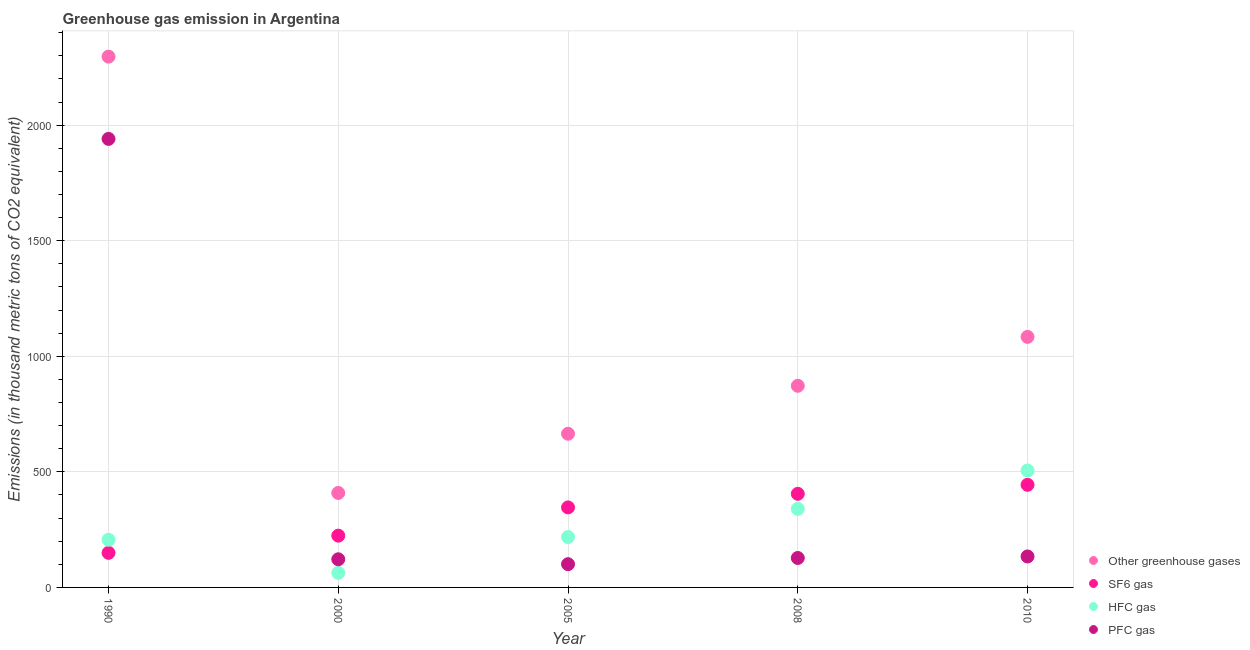Is the number of dotlines equal to the number of legend labels?
Ensure brevity in your answer.  Yes. What is the emission of greenhouse gases in 1990?
Provide a succinct answer. 2296.5. Across all years, what is the maximum emission of sf6 gas?
Keep it short and to the point. 444. Across all years, what is the minimum emission of pfc gas?
Your answer should be very brief. 100.6. What is the total emission of hfc gas in the graph?
Your answer should be very brief. 1333.4. What is the difference between the emission of greenhouse gases in 1990 and that in 2005?
Ensure brevity in your answer.  1631.6. What is the difference between the emission of hfc gas in 1990 and the emission of pfc gas in 2005?
Provide a short and direct response. 105.7. What is the average emission of greenhouse gases per year?
Provide a short and direct response. 1065.32. In the year 2010, what is the difference between the emission of pfc gas and emission of hfc gas?
Keep it short and to the point. -372. What is the ratio of the emission of pfc gas in 2005 to that in 2010?
Offer a very short reply. 0.75. What is the difference between the highest and the second highest emission of hfc gas?
Provide a short and direct response. 166. What is the difference between the highest and the lowest emission of sf6 gas?
Give a very brief answer. 294.4. Is the sum of the emission of pfc gas in 1990 and 2008 greater than the maximum emission of sf6 gas across all years?
Provide a short and direct response. Yes. Is it the case that in every year, the sum of the emission of greenhouse gases and emission of sf6 gas is greater than the emission of hfc gas?
Ensure brevity in your answer.  Yes. Does the emission of hfc gas monotonically increase over the years?
Provide a short and direct response. No. How many years are there in the graph?
Provide a succinct answer. 5. What is the difference between two consecutive major ticks on the Y-axis?
Ensure brevity in your answer.  500. Does the graph contain any zero values?
Provide a succinct answer. No. Does the graph contain grids?
Provide a short and direct response. Yes. Where does the legend appear in the graph?
Make the answer very short. Bottom right. What is the title of the graph?
Your response must be concise. Greenhouse gas emission in Argentina. Does "Offering training" appear as one of the legend labels in the graph?
Your response must be concise. No. What is the label or title of the X-axis?
Ensure brevity in your answer.  Year. What is the label or title of the Y-axis?
Your answer should be compact. Emissions (in thousand metric tons of CO2 equivalent). What is the Emissions (in thousand metric tons of CO2 equivalent) of Other greenhouse gases in 1990?
Your response must be concise. 2296.5. What is the Emissions (in thousand metric tons of CO2 equivalent) in SF6 gas in 1990?
Give a very brief answer. 149.6. What is the Emissions (in thousand metric tons of CO2 equivalent) in HFC gas in 1990?
Your response must be concise. 206.3. What is the Emissions (in thousand metric tons of CO2 equivalent) in PFC gas in 1990?
Your response must be concise. 1940.6. What is the Emissions (in thousand metric tons of CO2 equivalent) in Other greenhouse gases in 2000?
Ensure brevity in your answer.  408.8. What is the Emissions (in thousand metric tons of CO2 equivalent) of SF6 gas in 2000?
Offer a terse response. 224. What is the Emissions (in thousand metric tons of CO2 equivalent) in HFC gas in 2000?
Your response must be concise. 63. What is the Emissions (in thousand metric tons of CO2 equivalent) in PFC gas in 2000?
Make the answer very short. 121.8. What is the Emissions (in thousand metric tons of CO2 equivalent) of Other greenhouse gases in 2005?
Offer a very short reply. 664.9. What is the Emissions (in thousand metric tons of CO2 equivalent) in SF6 gas in 2005?
Your response must be concise. 346.2. What is the Emissions (in thousand metric tons of CO2 equivalent) in HFC gas in 2005?
Provide a succinct answer. 218.1. What is the Emissions (in thousand metric tons of CO2 equivalent) in PFC gas in 2005?
Your answer should be very brief. 100.6. What is the Emissions (in thousand metric tons of CO2 equivalent) in Other greenhouse gases in 2008?
Provide a short and direct response. 872.4. What is the Emissions (in thousand metric tons of CO2 equivalent) in SF6 gas in 2008?
Your response must be concise. 405. What is the Emissions (in thousand metric tons of CO2 equivalent) of HFC gas in 2008?
Give a very brief answer. 340. What is the Emissions (in thousand metric tons of CO2 equivalent) of PFC gas in 2008?
Keep it short and to the point. 127.4. What is the Emissions (in thousand metric tons of CO2 equivalent) of Other greenhouse gases in 2010?
Your answer should be compact. 1084. What is the Emissions (in thousand metric tons of CO2 equivalent) of SF6 gas in 2010?
Give a very brief answer. 444. What is the Emissions (in thousand metric tons of CO2 equivalent) in HFC gas in 2010?
Keep it short and to the point. 506. What is the Emissions (in thousand metric tons of CO2 equivalent) of PFC gas in 2010?
Make the answer very short. 134. Across all years, what is the maximum Emissions (in thousand metric tons of CO2 equivalent) in Other greenhouse gases?
Give a very brief answer. 2296.5. Across all years, what is the maximum Emissions (in thousand metric tons of CO2 equivalent) in SF6 gas?
Offer a very short reply. 444. Across all years, what is the maximum Emissions (in thousand metric tons of CO2 equivalent) in HFC gas?
Keep it short and to the point. 506. Across all years, what is the maximum Emissions (in thousand metric tons of CO2 equivalent) of PFC gas?
Give a very brief answer. 1940.6. Across all years, what is the minimum Emissions (in thousand metric tons of CO2 equivalent) in Other greenhouse gases?
Offer a very short reply. 408.8. Across all years, what is the minimum Emissions (in thousand metric tons of CO2 equivalent) of SF6 gas?
Provide a succinct answer. 149.6. Across all years, what is the minimum Emissions (in thousand metric tons of CO2 equivalent) in PFC gas?
Offer a very short reply. 100.6. What is the total Emissions (in thousand metric tons of CO2 equivalent) of Other greenhouse gases in the graph?
Your answer should be compact. 5326.6. What is the total Emissions (in thousand metric tons of CO2 equivalent) of SF6 gas in the graph?
Provide a succinct answer. 1568.8. What is the total Emissions (in thousand metric tons of CO2 equivalent) in HFC gas in the graph?
Provide a succinct answer. 1333.4. What is the total Emissions (in thousand metric tons of CO2 equivalent) in PFC gas in the graph?
Provide a succinct answer. 2424.4. What is the difference between the Emissions (in thousand metric tons of CO2 equivalent) of Other greenhouse gases in 1990 and that in 2000?
Keep it short and to the point. 1887.7. What is the difference between the Emissions (in thousand metric tons of CO2 equivalent) of SF6 gas in 1990 and that in 2000?
Offer a very short reply. -74.4. What is the difference between the Emissions (in thousand metric tons of CO2 equivalent) in HFC gas in 1990 and that in 2000?
Make the answer very short. 143.3. What is the difference between the Emissions (in thousand metric tons of CO2 equivalent) of PFC gas in 1990 and that in 2000?
Make the answer very short. 1818.8. What is the difference between the Emissions (in thousand metric tons of CO2 equivalent) in Other greenhouse gases in 1990 and that in 2005?
Ensure brevity in your answer.  1631.6. What is the difference between the Emissions (in thousand metric tons of CO2 equivalent) of SF6 gas in 1990 and that in 2005?
Give a very brief answer. -196.6. What is the difference between the Emissions (in thousand metric tons of CO2 equivalent) in PFC gas in 1990 and that in 2005?
Give a very brief answer. 1840. What is the difference between the Emissions (in thousand metric tons of CO2 equivalent) of Other greenhouse gases in 1990 and that in 2008?
Your response must be concise. 1424.1. What is the difference between the Emissions (in thousand metric tons of CO2 equivalent) of SF6 gas in 1990 and that in 2008?
Ensure brevity in your answer.  -255.4. What is the difference between the Emissions (in thousand metric tons of CO2 equivalent) of HFC gas in 1990 and that in 2008?
Keep it short and to the point. -133.7. What is the difference between the Emissions (in thousand metric tons of CO2 equivalent) of PFC gas in 1990 and that in 2008?
Provide a short and direct response. 1813.2. What is the difference between the Emissions (in thousand metric tons of CO2 equivalent) of Other greenhouse gases in 1990 and that in 2010?
Give a very brief answer. 1212.5. What is the difference between the Emissions (in thousand metric tons of CO2 equivalent) in SF6 gas in 1990 and that in 2010?
Ensure brevity in your answer.  -294.4. What is the difference between the Emissions (in thousand metric tons of CO2 equivalent) in HFC gas in 1990 and that in 2010?
Offer a terse response. -299.7. What is the difference between the Emissions (in thousand metric tons of CO2 equivalent) in PFC gas in 1990 and that in 2010?
Keep it short and to the point. 1806.6. What is the difference between the Emissions (in thousand metric tons of CO2 equivalent) of Other greenhouse gases in 2000 and that in 2005?
Keep it short and to the point. -256.1. What is the difference between the Emissions (in thousand metric tons of CO2 equivalent) in SF6 gas in 2000 and that in 2005?
Your answer should be compact. -122.2. What is the difference between the Emissions (in thousand metric tons of CO2 equivalent) in HFC gas in 2000 and that in 2005?
Offer a terse response. -155.1. What is the difference between the Emissions (in thousand metric tons of CO2 equivalent) in PFC gas in 2000 and that in 2005?
Your answer should be compact. 21.2. What is the difference between the Emissions (in thousand metric tons of CO2 equivalent) in Other greenhouse gases in 2000 and that in 2008?
Give a very brief answer. -463.6. What is the difference between the Emissions (in thousand metric tons of CO2 equivalent) in SF6 gas in 2000 and that in 2008?
Provide a short and direct response. -181. What is the difference between the Emissions (in thousand metric tons of CO2 equivalent) in HFC gas in 2000 and that in 2008?
Keep it short and to the point. -277. What is the difference between the Emissions (in thousand metric tons of CO2 equivalent) of Other greenhouse gases in 2000 and that in 2010?
Provide a short and direct response. -675.2. What is the difference between the Emissions (in thousand metric tons of CO2 equivalent) of SF6 gas in 2000 and that in 2010?
Your answer should be very brief. -220. What is the difference between the Emissions (in thousand metric tons of CO2 equivalent) of HFC gas in 2000 and that in 2010?
Make the answer very short. -443. What is the difference between the Emissions (in thousand metric tons of CO2 equivalent) in PFC gas in 2000 and that in 2010?
Your response must be concise. -12.2. What is the difference between the Emissions (in thousand metric tons of CO2 equivalent) in Other greenhouse gases in 2005 and that in 2008?
Your answer should be very brief. -207.5. What is the difference between the Emissions (in thousand metric tons of CO2 equivalent) in SF6 gas in 2005 and that in 2008?
Make the answer very short. -58.8. What is the difference between the Emissions (in thousand metric tons of CO2 equivalent) of HFC gas in 2005 and that in 2008?
Make the answer very short. -121.9. What is the difference between the Emissions (in thousand metric tons of CO2 equivalent) in PFC gas in 2005 and that in 2008?
Offer a terse response. -26.8. What is the difference between the Emissions (in thousand metric tons of CO2 equivalent) of Other greenhouse gases in 2005 and that in 2010?
Provide a succinct answer. -419.1. What is the difference between the Emissions (in thousand metric tons of CO2 equivalent) of SF6 gas in 2005 and that in 2010?
Offer a terse response. -97.8. What is the difference between the Emissions (in thousand metric tons of CO2 equivalent) of HFC gas in 2005 and that in 2010?
Ensure brevity in your answer.  -287.9. What is the difference between the Emissions (in thousand metric tons of CO2 equivalent) in PFC gas in 2005 and that in 2010?
Your answer should be very brief. -33.4. What is the difference between the Emissions (in thousand metric tons of CO2 equivalent) in Other greenhouse gases in 2008 and that in 2010?
Give a very brief answer. -211.6. What is the difference between the Emissions (in thousand metric tons of CO2 equivalent) of SF6 gas in 2008 and that in 2010?
Your response must be concise. -39. What is the difference between the Emissions (in thousand metric tons of CO2 equivalent) in HFC gas in 2008 and that in 2010?
Your answer should be very brief. -166. What is the difference between the Emissions (in thousand metric tons of CO2 equivalent) of Other greenhouse gases in 1990 and the Emissions (in thousand metric tons of CO2 equivalent) of SF6 gas in 2000?
Offer a very short reply. 2072.5. What is the difference between the Emissions (in thousand metric tons of CO2 equivalent) in Other greenhouse gases in 1990 and the Emissions (in thousand metric tons of CO2 equivalent) in HFC gas in 2000?
Give a very brief answer. 2233.5. What is the difference between the Emissions (in thousand metric tons of CO2 equivalent) of Other greenhouse gases in 1990 and the Emissions (in thousand metric tons of CO2 equivalent) of PFC gas in 2000?
Offer a very short reply. 2174.7. What is the difference between the Emissions (in thousand metric tons of CO2 equivalent) in SF6 gas in 1990 and the Emissions (in thousand metric tons of CO2 equivalent) in HFC gas in 2000?
Ensure brevity in your answer.  86.6. What is the difference between the Emissions (in thousand metric tons of CO2 equivalent) in SF6 gas in 1990 and the Emissions (in thousand metric tons of CO2 equivalent) in PFC gas in 2000?
Keep it short and to the point. 27.8. What is the difference between the Emissions (in thousand metric tons of CO2 equivalent) in HFC gas in 1990 and the Emissions (in thousand metric tons of CO2 equivalent) in PFC gas in 2000?
Give a very brief answer. 84.5. What is the difference between the Emissions (in thousand metric tons of CO2 equivalent) in Other greenhouse gases in 1990 and the Emissions (in thousand metric tons of CO2 equivalent) in SF6 gas in 2005?
Give a very brief answer. 1950.3. What is the difference between the Emissions (in thousand metric tons of CO2 equivalent) of Other greenhouse gases in 1990 and the Emissions (in thousand metric tons of CO2 equivalent) of HFC gas in 2005?
Make the answer very short. 2078.4. What is the difference between the Emissions (in thousand metric tons of CO2 equivalent) in Other greenhouse gases in 1990 and the Emissions (in thousand metric tons of CO2 equivalent) in PFC gas in 2005?
Make the answer very short. 2195.9. What is the difference between the Emissions (in thousand metric tons of CO2 equivalent) in SF6 gas in 1990 and the Emissions (in thousand metric tons of CO2 equivalent) in HFC gas in 2005?
Your answer should be very brief. -68.5. What is the difference between the Emissions (in thousand metric tons of CO2 equivalent) in HFC gas in 1990 and the Emissions (in thousand metric tons of CO2 equivalent) in PFC gas in 2005?
Ensure brevity in your answer.  105.7. What is the difference between the Emissions (in thousand metric tons of CO2 equivalent) of Other greenhouse gases in 1990 and the Emissions (in thousand metric tons of CO2 equivalent) of SF6 gas in 2008?
Ensure brevity in your answer.  1891.5. What is the difference between the Emissions (in thousand metric tons of CO2 equivalent) of Other greenhouse gases in 1990 and the Emissions (in thousand metric tons of CO2 equivalent) of HFC gas in 2008?
Keep it short and to the point. 1956.5. What is the difference between the Emissions (in thousand metric tons of CO2 equivalent) of Other greenhouse gases in 1990 and the Emissions (in thousand metric tons of CO2 equivalent) of PFC gas in 2008?
Your answer should be very brief. 2169.1. What is the difference between the Emissions (in thousand metric tons of CO2 equivalent) in SF6 gas in 1990 and the Emissions (in thousand metric tons of CO2 equivalent) in HFC gas in 2008?
Offer a terse response. -190.4. What is the difference between the Emissions (in thousand metric tons of CO2 equivalent) in HFC gas in 1990 and the Emissions (in thousand metric tons of CO2 equivalent) in PFC gas in 2008?
Your response must be concise. 78.9. What is the difference between the Emissions (in thousand metric tons of CO2 equivalent) of Other greenhouse gases in 1990 and the Emissions (in thousand metric tons of CO2 equivalent) of SF6 gas in 2010?
Provide a short and direct response. 1852.5. What is the difference between the Emissions (in thousand metric tons of CO2 equivalent) of Other greenhouse gases in 1990 and the Emissions (in thousand metric tons of CO2 equivalent) of HFC gas in 2010?
Give a very brief answer. 1790.5. What is the difference between the Emissions (in thousand metric tons of CO2 equivalent) in Other greenhouse gases in 1990 and the Emissions (in thousand metric tons of CO2 equivalent) in PFC gas in 2010?
Provide a succinct answer. 2162.5. What is the difference between the Emissions (in thousand metric tons of CO2 equivalent) in SF6 gas in 1990 and the Emissions (in thousand metric tons of CO2 equivalent) in HFC gas in 2010?
Give a very brief answer. -356.4. What is the difference between the Emissions (in thousand metric tons of CO2 equivalent) of HFC gas in 1990 and the Emissions (in thousand metric tons of CO2 equivalent) of PFC gas in 2010?
Your answer should be compact. 72.3. What is the difference between the Emissions (in thousand metric tons of CO2 equivalent) in Other greenhouse gases in 2000 and the Emissions (in thousand metric tons of CO2 equivalent) in SF6 gas in 2005?
Offer a very short reply. 62.6. What is the difference between the Emissions (in thousand metric tons of CO2 equivalent) of Other greenhouse gases in 2000 and the Emissions (in thousand metric tons of CO2 equivalent) of HFC gas in 2005?
Your answer should be very brief. 190.7. What is the difference between the Emissions (in thousand metric tons of CO2 equivalent) in Other greenhouse gases in 2000 and the Emissions (in thousand metric tons of CO2 equivalent) in PFC gas in 2005?
Your answer should be compact. 308.2. What is the difference between the Emissions (in thousand metric tons of CO2 equivalent) in SF6 gas in 2000 and the Emissions (in thousand metric tons of CO2 equivalent) in HFC gas in 2005?
Offer a terse response. 5.9. What is the difference between the Emissions (in thousand metric tons of CO2 equivalent) of SF6 gas in 2000 and the Emissions (in thousand metric tons of CO2 equivalent) of PFC gas in 2005?
Your response must be concise. 123.4. What is the difference between the Emissions (in thousand metric tons of CO2 equivalent) of HFC gas in 2000 and the Emissions (in thousand metric tons of CO2 equivalent) of PFC gas in 2005?
Provide a succinct answer. -37.6. What is the difference between the Emissions (in thousand metric tons of CO2 equivalent) in Other greenhouse gases in 2000 and the Emissions (in thousand metric tons of CO2 equivalent) in HFC gas in 2008?
Your answer should be very brief. 68.8. What is the difference between the Emissions (in thousand metric tons of CO2 equivalent) of Other greenhouse gases in 2000 and the Emissions (in thousand metric tons of CO2 equivalent) of PFC gas in 2008?
Offer a very short reply. 281.4. What is the difference between the Emissions (in thousand metric tons of CO2 equivalent) of SF6 gas in 2000 and the Emissions (in thousand metric tons of CO2 equivalent) of HFC gas in 2008?
Provide a succinct answer. -116. What is the difference between the Emissions (in thousand metric tons of CO2 equivalent) of SF6 gas in 2000 and the Emissions (in thousand metric tons of CO2 equivalent) of PFC gas in 2008?
Your response must be concise. 96.6. What is the difference between the Emissions (in thousand metric tons of CO2 equivalent) in HFC gas in 2000 and the Emissions (in thousand metric tons of CO2 equivalent) in PFC gas in 2008?
Provide a short and direct response. -64.4. What is the difference between the Emissions (in thousand metric tons of CO2 equivalent) of Other greenhouse gases in 2000 and the Emissions (in thousand metric tons of CO2 equivalent) of SF6 gas in 2010?
Make the answer very short. -35.2. What is the difference between the Emissions (in thousand metric tons of CO2 equivalent) of Other greenhouse gases in 2000 and the Emissions (in thousand metric tons of CO2 equivalent) of HFC gas in 2010?
Your answer should be very brief. -97.2. What is the difference between the Emissions (in thousand metric tons of CO2 equivalent) in Other greenhouse gases in 2000 and the Emissions (in thousand metric tons of CO2 equivalent) in PFC gas in 2010?
Provide a short and direct response. 274.8. What is the difference between the Emissions (in thousand metric tons of CO2 equivalent) of SF6 gas in 2000 and the Emissions (in thousand metric tons of CO2 equivalent) of HFC gas in 2010?
Offer a terse response. -282. What is the difference between the Emissions (in thousand metric tons of CO2 equivalent) in HFC gas in 2000 and the Emissions (in thousand metric tons of CO2 equivalent) in PFC gas in 2010?
Offer a terse response. -71. What is the difference between the Emissions (in thousand metric tons of CO2 equivalent) of Other greenhouse gases in 2005 and the Emissions (in thousand metric tons of CO2 equivalent) of SF6 gas in 2008?
Your response must be concise. 259.9. What is the difference between the Emissions (in thousand metric tons of CO2 equivalent) of Other greenhouse gases in 2005 and the Emissions (in thousand metric tons of CO2 equivalent) of HFC gas in 2008?
Offer a very short reply. 324.9. What is the difference between the Emissions (in thousand metric tons of CO2 equivalent) of Other greenhouse gases in 2005 and the Emissions (in thousand metric tons of CO2 equivalent) of PFC gas in 2008?
Provide a short and direct response. 537.5. What is the difference between the Emissions (in thousand metric tons of CO2 equivalent) in SF6 gas in 2005 and the Emissions (in thousand metric tons of CO2 equivalent) in PFC gas in 2008?
Offer a terse response. 218.8. What is the difference between the Emissions (in thousand metric tons of CO2 equivalent) of HFC gas in 2005 and the Emissions (in thousand metric tons of CO2 equivalent) of PFC gas in 2008?
Give a very brief answer. 90.7. What is the difference between the Emissions (in thousand metric tons of CO2 equivalent) of Other greenhouse gases in 2005 and the Emissions (in thousand metric tons of CO2 equivalent) of SF6 gas in 2010?
Keep it short and to the point. 220.9. What is the difference between the Emissions (in thousand metric tons of CO2 equivalent) of Other greenhouse gases in 2005 and the Emissions (in thousand metric tons of CO2 equivalent) of HFC gas in 2010?
Keep it short and to the point. 158.9. What is the difference between the Emissions (in thousand metric tons of CO2 equivalent) in Other greenhouse gases in 2005 and the Emissions (in thousand metric tons of CO2 equivalent) in PFC gas in 2010?
Your response must be concise. 530.9. What is the difference between the Emissions (in thousand metric tons of CO2 equivalent) of SF6 gas in 2005 and the Emissions (in thousand metric tons of CO2 equivalent) of HFC gas in 2010?
Make the answer very short. -159.8. What is the difference between the Emissions (in thousand metric tons of CO2 equivalent) of SF6 gas in 2005 and the Emissions (in thousand metric tons of CO2 equivalent) of PFC gas in 2010?
Provide a succinct answer. 212.2. What is the difference between the Emissions (in thousand metric tons of CO2 equivalent) in HFC gas in 2005 and the Emissions (in thousand metric tons of CO2 equivalent) in PFC gas in 2010?
Your answer should be compact. 84.1. What is the difference between the Emissions (in thousand metric tons of CO2 equivalent) in Other greenhouse gases in 2008 and the Emissions (in thousand metric tons of CO2 equivalent) in SF6 gas in 2010?
Provide a succinct answer. 428.4. What is the difference between the Emissions (in thousand metric tons of CO2 equivalent) of Other greenhouse gases in 2008 and the Emissions (in thousand metric tons of CO2 equivalent) of HFC gas in 2010?
Make the answer very short. 366.4. What is the difference between the Emissions (in thousand metric tons of CO2 equivalent) of Other greenhouse gases in 2008 and the Emissions (in thousand metric tons of CO2 equivalent) of PFC gas in 2010?
Make the answer very short. 738.4. What is the difference between the Emissions (in thousand metric tons of CO2 equivalent) in SF6 gas in 2008 and the Emissions (in thousand metric tons of CO2 equivalent) in HFC gas in 2010?
Provide a short and direct response. -101. What is the difference between the Emissions (in thousand metric tons of CO2 equivalent) in SF6 gas in 2008 and the Emissions (in thousand metric tons of CO2 equivalent) in PFC gas in 2010?
Keep it short and to the point. 271. What is the difference between the Emissions (in thousand metric tons of CO2 equivalent) of HFC gas in 2008 and the Emissions (in thousand metric tons of CO2 equivalent) of PFC gas in 2010?
Provide a short and direct response. 206. What is the average Emissions (in thousand metric tons of CO2 equivalent) in Other greenhouse gases per year?
Offer a terse response. 1065.32. What is the average Emissions (in thousand metric tons of CO2 equivalent) of SF6 gas per year?
Provide a short and direct response. 313.76. What is the average Emissions (in thousand metric tons of CO2 equivalent) of HFC gas per year?
Give a very brief answer. 266.68. What is the average Emissions (in thousand metric tons of CO2 equivalent) in PFC gas per year?
Provide a succinct answer. 484.88. In the year 1990, what is the difference between the Emissions (in thousand metric tons of CO2 equivalent) in Other greenhouse gases and Emissions (in thousand metric tons of CO2 equivalent) in SF6 gas?
Your answer should be very brief. 2146.9. In the year 1990, what is the difference between the Emissions (in thousand metric tons of CO2 equivalent) of Other greenhouse gases and Emissions (in thousand metric tons of CO2 equivalent) of HFC gas?
Your answer should be compact. 2090.2. In the year 1990, what is the difference between the Emissions (in thousand metric tons of CO2 equivalent) in Other greenhouse gases and Emissions (in thousand metric tons of CO2 equivalent) in PFC gas?
Provide a short and direct response. 355.9. In the year 1990, what is the difference between the Emissions (in thousand metric tons of CO2 equivalent) of SF6 gas and Emissions (in thousand metric tons of CO2 equivalent) of HFC gas?
Offer a terse response. -56.7. In the year 1990, what is the difference between the Emissions (in thousand metric tons of CO2 equivalent) in SF6 gas and Emissions (in thousand metric tons of CO2 equivalent) in PFC gas?
Provide a short and direct response. -1791. In the year 1990, what is the difference between the Emissions (in thousand metric tons of CO2 equivalent) in HFC gas and Emissions (in thousand metric tons of CO2 equivalent) in PFC gas?
Your response must be concise. -1734.3. In the year 2000, what is the difference between the Emissions (in thousand metric tons of CO2 equivalent) in Other greenhouse gases and Emissions (in thousand metric tons of CO2 equivalent) in SF6 gas?
Provide a short and direct response. 184.8. In the year 2000, what is the difference between the Emissions (in thousand metric tons of CO2 equivalent) in Other greenhouse gases and Emissions (in thousand metric tons of CO2 equivalent) in HFC gas?
Offer a very short reply. 345.8. In the year 2000, what is the difference between the Emissions (in thousand metric tons of CO2 equivalent) of Other greenhouse gases and Emissions (in thousand metric tons of CO2 equivalent) of PFC gas?
Offer a terse response. 287. In the year 2000, what is the difference between the Emissions (in thousand metric tons of CO2 equivalent) of SF6 gas and Emissions (in thousand metric tons of CO2 equivalent) of HFC gas?
Make the answer very short. 161. In the year 2000, what is the difference between the Emissions (in thousand metric tons of CO2 equivalent) in SF6 gas and Emissions (in thousand metric tons of CO2 equivalent) in PFC gas?
Make the answer very short. 102.2. In the year 2000, what is the difference between the Emissions (in thousand metric tons of CO2 equivalent) of HFC gas and Emissions (in thousand metric tons of CO2 equivalent) of PFC gas?
Keep it short and to the point. -58.8. In the year 2005, what is the difference between the Emissions (in thousand metric tons of CO2 equivalent) in Other greenhouse gases and Emissions (in thousand metric tons of CO2 equivalent) in SF6 gas?
Offer a terse response. 318.7. In the year 2005, what is the difference between the Emissions (in thousand metric tons of CO2 equivalent) in Other greenhouse gases and Emissions (in thousand metric tons of CO2 equivalent) in HFC gas?
Make the answer very short. 446.8. In the year 2005, what is the difference between the Emissions (in thousand metric tons of CO2 equivalent) in Other greenhouse gases and Emissions (in thousand metric tons of CO2 equivalent) in PFC gas?
Offer a very short reply. 564.3. In the year 2005, what is the difference between the Emissions (in thousand metric tons of CO2 equivalent) in SF6 gas and Emissions (in thousand metric tons of CO2 equivalent) in HFC gas?
Make the answer very short. 128.1. In the year 2005, what is the difference between the Emissions (in thousand metric tons of CO2 equivalent) of SF6 gas and Emissions (in thousand metric tons of CO2 equivalent) of PFC gas?
Offer a very short reply. 245.6. In the year 2005, what is the difference between the Emissions (in thousand metric tons of CO2 equivalent) in HFC gas and Emissions (in thousand metric tons of CO2 equivalent) in PFC gas?
Ensure brevity in your answer.  117.5. In the year 2008, what is the difference between the Emissions (in thousand metric tons of CO2 equivalent) in Other greenhouse gases and Emissions (in thousand metric tons of CO2 equivalent) in SF6 gas?
Give a very brief answer. 467.4. In the year 2008, what is the difference between the Emissions (in thousand metric tons of CO2 equivalent) in Other greenhouse gases and Emissions (in thousand metric tons of CO2 equivalent) in HFC gas?
Your response must be concise. 532.4. In the year 2008, what is the difference between the Emissions (in thousand metric tons of CO2 equivalent) in Other greenhouse gases and Emissions (in thousand metric tons of CO2 equivalent) in PFC gas?
Offer a terse response. 745. In the year 2008, what is the difference between the Emissions (in thousand metric tons of CO2 equivalent) of SF6 gas and Emissions (in thousand metric tons of CO2 equivalent) of PFC gas?
Keep it short and to the point. 277.6. In the year 2008, what is the difference between the Emissions (in thousand metric tons of CO2 equivalent) of HFC gas and Emissions (in thousand metric tons of CO2 equivalent) of PFC gas?
Provide a short and direct response. 212.6. In the year 2010, what is the difference between the Emissions (in thousand metric tons of CO2 equivalent) of Other greenhouse gases and Emissions (in thousand metric tons of CO2 equivalent) of SF6 gas?
Provide a succinct answer. 640. In the year 2010, what is the difference between the Emissions (in thousand metric tons of CO2 equivalent) in Other greenhouse gases and Emissions (in thousand metric tons of CO2 equivalent) in HFC gas?
Make the answer very short. 578. In the year 2010, what is the difference between the Emissions (in thousand metric tons of CO2 equivalent) of Other greenhouse gases and Emissions (in thousand metric tons of CO2 equivalent) of PFC gas?
Provide a short and direct response. 950. In the year 2010, what is the difference between the Emissions (in thousand metric tons of CO2 equivalent) in SF6 gas and Emissions (in thousand metric tons of CO2 equivalent) in HFC gas?
Make the answer very short. -62. In the year 2010, what is the difference between the Emissions (in thousand metric tons of CO2 equivalent) in SF6 gas and Emissions (in thousand metric tons of CO2 equivalent) in PFC gas?
Provide a short and direct response. 310. In the year 2010, what is the difference between the Emissions (in thousand metric tons of CO2 equivalent) in HFC gas and Emissions (in thousand metric tons of CO2 equivalent) in PFC gas?
Make the answer very short. 372. What is the ratio of the Emissions (in thousand metric tons of CO2 equivalent) in Other greenhouse gases in 1990 to that in 2000?
Make the answer very short. 5.62. What is the ratio of the Emissions (in thousand metric tons of CO2 equivalent) of SF6 gas in 1990 to that in 2000?
Your answer should be very brief. 0.67. What is the ratio of the Emissions (in thousand metric tons of CO2 equivalent) in HFC gas in 1990 to that in 2000?
Your answer should be very brief. 3.27. What is the ratio of the Emissions (in thousand metric tons of CO2 equivalent) of PFC gas in 1990 to that in 2000?
Offer a terse response. 15.93. What is the ratio of the Emissions (in thousand metric tons of CO2 equivalent) in Other greenhouse gases in 1990 to that in 2005?
Ensure brevity in your answer.  3.45. What is the ratio of the Emissions (in thousand metric tons of CO2 equivalent) in SF6 gas in 1990 to that in 2005?
Your answer should be compact. 0.43. What is the ratio of the Emissions (in thousand metric tons of CO2 equivalent) in HFC gas in 1990 to that in 2005?
Your response must be concise. 0.95. What is the ratio of the Emissions (in thousand metric tons of CO2 equivalent) of PFC gas in 1990 to that in 2005?
Provide a succinct answer. 19.29. What is the ratio of the Emissions (in thousand metric tons of CO2 equivalent) in Other greenhouse gases in 1990 to that in 2008?
Give a very brief answer. 2.63. What is the ratio of the Emissions (in thousand metric tons of CO2 equivalent) of SF6 gas in 1990 to that in 2008?
Your answer should be very brief. 0.37. What is the ratio of the Emissions (in thousand metric tons of CO2 equivalent) in HFC gas in 1990 to that in 2008?
Ensure brevity in your answer.  0.61. What is the ratio of the Emissions (in thousand metric tons of CO2 equivalent) in PFC gas in 1990 to that in 2008?
Your answer should be very brief. 15.23. What is the ratio of the Emissions (in thousand metric tons of CO2 equivalent) of Other greenhouse gases in 1990 to that in 2010?
Your answer should be very brief. 2.12. What is the ratio of the Emissions (in thousand metric tons of CO2 equivalent) of SF6 gas in 1990 to that in 2010?
Keep it short and to the point. 0.34. What is the ratio of the Emissions (in thousand metric tons of CO2 equivalent) of HFC gas in 1990 to that in 2010?
Your response must be concise. 0.41. What is the ratio of the Emissions (in thousand metric tons of CO2 equivalent) of PFC gas in 1990 to that in 2010?
Your answer should be very brief. 14.48. What is the ratio of the Emissions (in thousand metric tons of CO2 equivalent) in Other greenhouse gases in 2000 to that in 2005?
Your answer should be very brief. 0.61. What is the ratio of the Emissions (in thousand metric tons of CO2 equivalent) in SF6 gas in 2000 to that in 2005?
Make the answer very short. 0.65. What is the ratio of the Emissions (in thousand metric tons of CO2 equivalent) of HFC gas in 2000 to that in 2005?
Ensure brevity in your answer.  0.29. What is the ratio of the Emissions (in thousand metric tons of CO2 equivalent) of PFC gas in 2000 to that in 2005?
Offer a terse response. 1.21. What is the ratio of the Emissions (in thousand metric tons of CO2 equivalent) in Other greenhouse gases in 2000 to that in 2008?
Provide a short and direct response. 0.47. What is the ratio of the Emissions (in thousand metric tons of CO2 equivalent) in SF6 gas in 2000 to that in 2008?
Give a very brief answer. 0.55. What is the ratio of the Emissions (in thousand metric tons of CO2 equivalent) of HFC gas in 2000 to that in 2008?
Provide a short and direct response. 0.19. What is the ratio of the Emissions (in thousand metric tons of CO2 equivalent) of PFC gas in 2000 to that in 2008?
Offer a very short reply. 0.96. What is the ratio of the Emissions (in thousand metric tons of CO2 equivalent) of Other greenhouse gases in 2000 to that in 2010?
Give a very brief answer. 0.38. What is the ratio of the Emissions (in thousand metric tons of CO2 equivalent) in SF6 gas in 2000 to that in 2010?
Your response must be concise. 0.5. What is the ratio of the Emissions (in thousand metric tons of CO2 equivalent) in HFC gas in 2000 to that in 2010?
Keep it short and to the point. 0.12. What is the ratio of the Emissions (in thousand metric tons of CO2 equivalent) of PFC gas in 2000 to that in 2010?
Provide a succinct answer. 0.91. What is the ratio of the Emissions (in thousand metric tons of CO2 equivalent) in Other greenhouse gases in 2005 to that in 2008?
Offer a terse response. 0.76. What is the ratio of the Emissions (in thousand metric tons of CO2 equivalent) of SF6 gas in 2005 to that in 2008?
Give a very brief answer. 0.85. What is the ratio of the Emissions (in thousand metric tons of CO2 equivalent) of HFC gas in 2005 to that in 2008?
Give a very brief answer. 0.64. What is the ratio of the Emissions (in thousand metric tons of CO2 equivalent) of PFC gas in 2005 to that in 2008?
Make the answer very short. 0.79. What is the ratio of the Emissions (in thousand metric tons of CO2 equivalent) of Other greenhouse gases in 2005 to that in 2010?
Offer a terse response. 0.61. What is the ratio of the Emissions (in thousand metric tons of CO2 equivalent) in SF6 gas in 2005 to that in 2010?
Make the answer very short. 0.78. What is the ratio of the Emissions (in thousand metric tons of CO2 equivalent) in HFC gas in 2005 to that in 2010?
Your response must be concise. 0.43. What is the ratio of the Emissions (in thousand metric tons of CO2 equivalent) of PFC gas in 2005 to that in 2010?
Provide a succinct answer. 0.75. What is the ratio of the Emissions (in thousand metric tons of CO2 equivalent) of Other greenhouse gases in 2008 to that in 2010?
Your answer should be compact. 0.8. What is the ratio of the Emissions (in thousand metric tons of CO2 equivalent) of SF6 gas in 2008 to that in 2010?
Provide a succinct answer. 0.91. What is the ratio of the Emissions (in thousand metric tons of CO2 equivalent) in HFC gas in 2008 to that in 2010?
Offer a terse response. 0.67. What is the ratio of the Emissions (in thousand metric tons of CO2 equivalent) of PFC gas in 2008 to that in 2010?
Your response must be concise. 0.95. What is the difference between the highest and the second highest Emissions (in thousand metric tons of CO2 equivalent) of Other greenhouse gases?
Provide a succinct answer. 1212.5. What is the difference between the highest and the second highest Emissions (in thousand metric tons of CO2 equivalent) of HFC gas?
Provide a short and direct response. 166. What is the difference between the highest and the second highest Emissions (in thousand metric tons of CO2 equivalent) in PFC gas?
Keep it short and to the point. 1806.6. What is the difference between the highest and the lowest Emissions (in thousand metric tons of CO2 equivalent) of Other greenhouse gases?
Provide a short and direct response. 1887.7. What is the difference between the highest and the lowest Emissions (in thousand metric tons of CO2 equivalent) of SF6 gas?
Your response must be concise. 294.4. What is the difference between the highest and the lowest Emissions (in thousand metric tons of CO2 equivalent) in HFC gas?
Your answer should be very brief. 443. What is the difference between the highest and the lowest Emissions (in thousand metric tons of CO2 equivalent) of PFC gas?
Make the answer very short. 1840. 